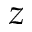<formula> <loc_0><loc_0><loc_500><loc_500>z</formula> 